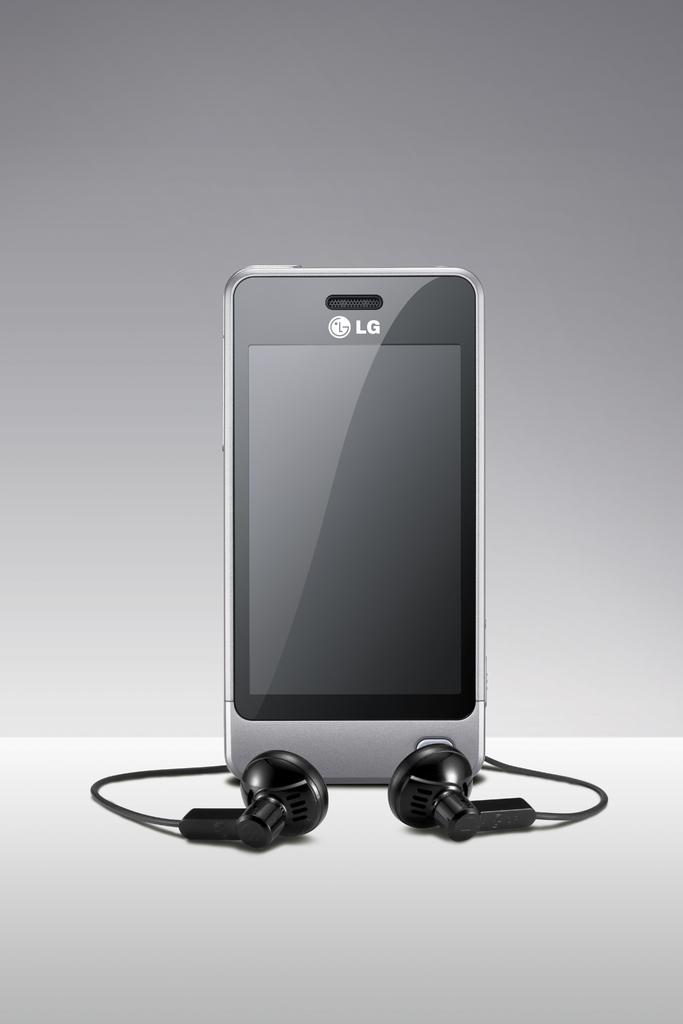<image>
Render a clear and concise summary of the photo. LG is the brand of this cellphone and earbuds. 